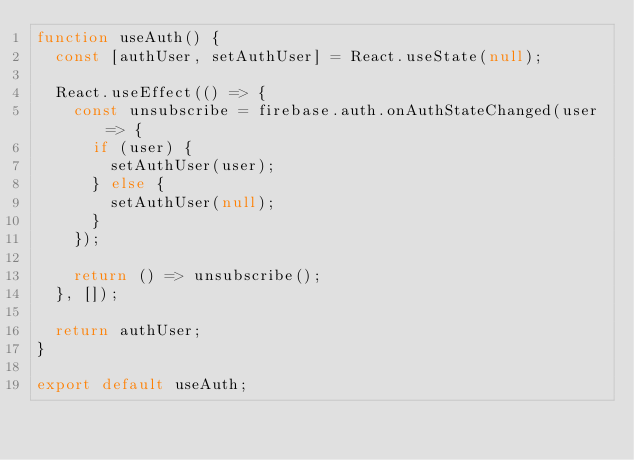<code> <loc_0><loc_0><loc_500><loc_500><_JavaScript_>function useAuth() {
  const [authUser, setAuthUser] = React.useState(null);

  React.useEffect(() => {
    const unsubscribe = firebase.auth.onAuthStateChanged(user => {
      if (user) {
        setAuthUser(user);
      } else {
        setAuthUser(null);
      }
    });

    return () => unsubscribe();
  }, []);

  return authUser;
}

export default useAuth;
</code> 